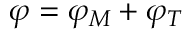Convert formula to latex. <formula><loc_0><loc_0><loc_500><loc_500>\varphi = \varphi _ { M } + \varphi _ { T }</formula> 